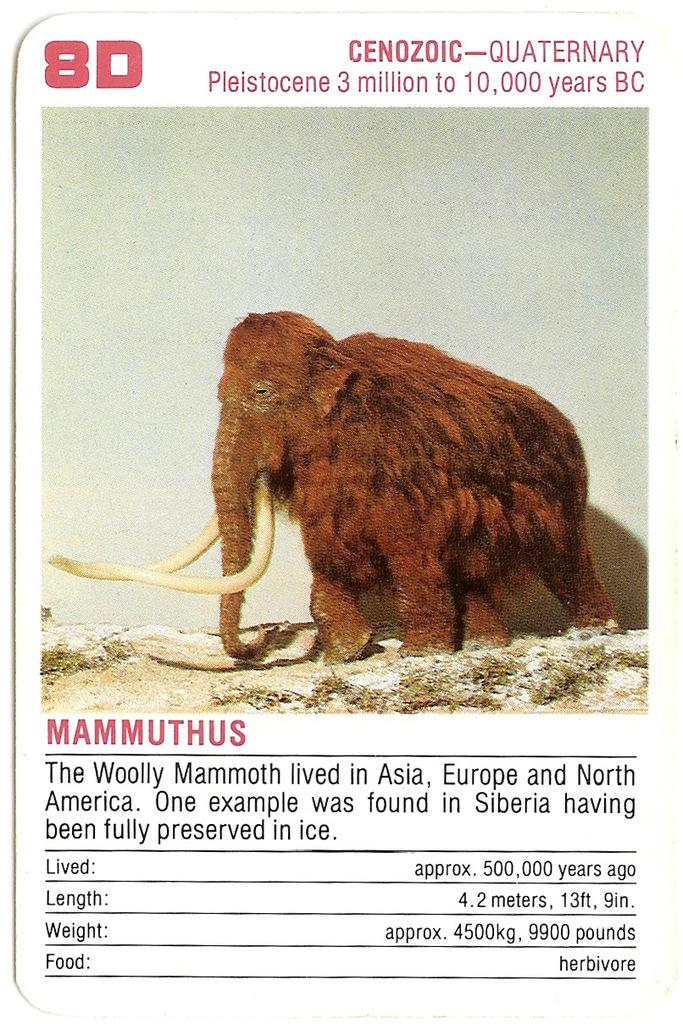What is the main object in the picture? There is an information card in the picture. What is depicted on the information card? The information card contains a picture of a mammoth animal. What additional information is provided on the information card? The information card includes details about the mammoth animal. What type of chalk is being used to draw the mammoth animal on the information card? There is no chalk present in the image, and the mammoth animal is depicted in a picture, not drawn on the information card. 